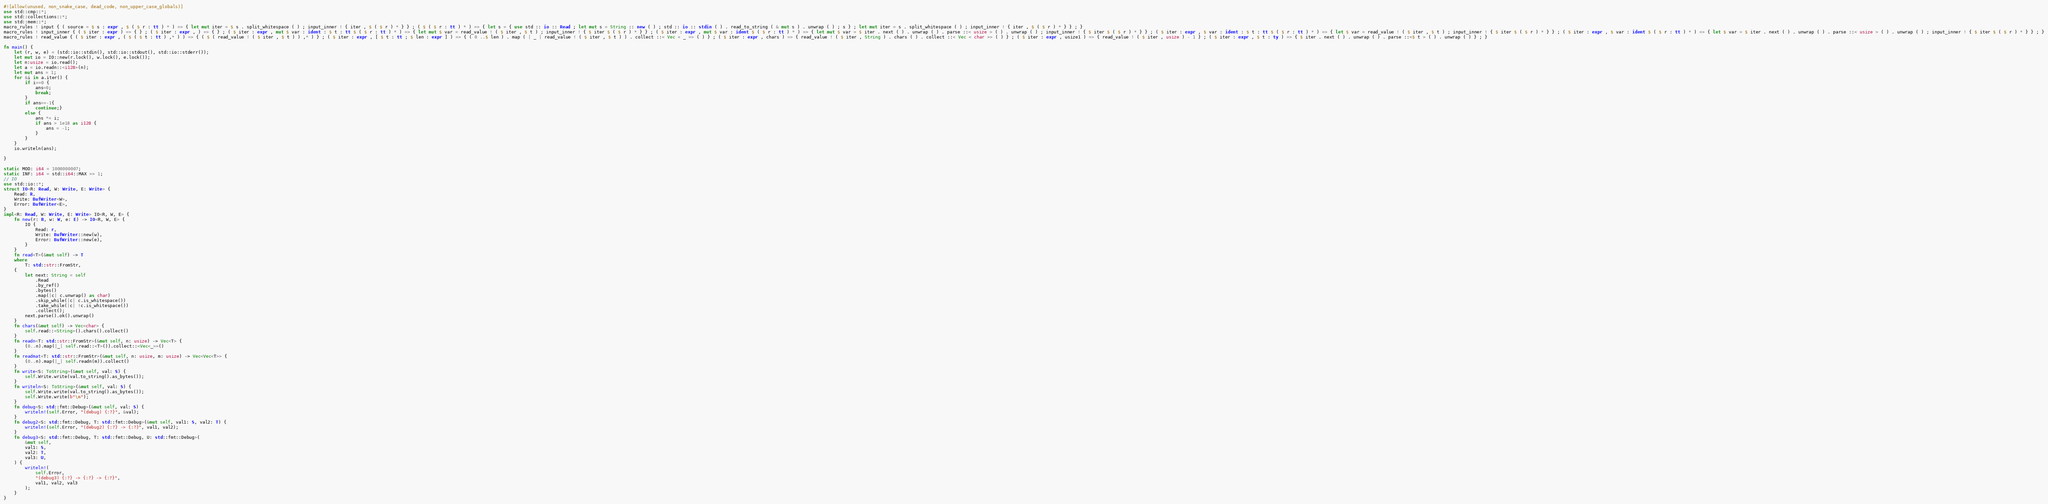<code> <loc_0><loc_0><loc_500><loc_500><_Rust_>#![allow(unused, non_snake_case, dead_code, non_upper_case_globals)]
use std::cmp::*;
use std::collections::*;
use std::mem::*;
macro_rules ! input { ( source = $ s : expr , $ ( $ r : tt ) * ) => { let mut iter = $ s . split_whitespace ( ) ; input_inner ! { iter , $ ( $ r ) * } } ; ( $ ( $ r : tt ) * ) => { let s = { use std :: io :: Read ; let mut s = String :: new ( ) ; std :: io :: stdin ( ) . read_to_string ( & mut s ) . unwrap ( ) ; s } ; let mut iter = s . split_whitespace ( ) ; input_inner ! { iter , $ ( $ r ) * } } ; }
macro_rules ! input_inner { ( $ iter : expr ) => { } ; ( $ iter : expr , ) => { } ; ( $ iter : expr , mut $ var : ident : $ t : tt $ ( $ r : tt ) * ) => { let mut $ var = read_value ! ( $ iter , $ t ) ; input_inner ! { $ iter $ ( $ r ) * } } ; ( $ iter : expr , mut $ var : ident $ ( $ r : tt ) * ) => { let mut $ var = $ iter . next ( ) . unwrap ( ) . parse ::< usize > ( ) . unwrap ( ) ; input_inner ! { $ iter $ ( $ r ) * } } ; ( $ iter : expr , $ var : ident : $ t : tt $ ( $ r : tt ) * ) => { let $ var = read_value ! ( $ iter , $ t ) ; input_inner ! { $ iter $ ( $ r ) * } } ; ( $ iter : expr , $ var : ident $ ( $ r : tt ) * ) => { let $ var = $ iter . next ( ) . unwrap ( ) . parse ::< usize > ( ) . unwrap ( ) ; input_inner ! { $ iter $ ( $ r ) * } } ; }
macro_rules ! read_value { ( $ iter : expr , ( $ ( $ t : tt ) ,* ) ) => { ( $ ( read_value ! ( $ iter , $ t ) ) ,* ) } ; ( $ iter : expr , [ $ t : tt ; $ len : expr ] ) => { ( 0 ..$ len ) . map ( | _ | read_value ! ( $ iter , $ t ) ) . collect ::< Vec < _ >> ( ) } ; ( $ iter : expr , chars ) => { read_value ! ( $ iter , String ) . chars ( ) . collect ::< Vec < char >> ( ) } ; ( $ iter : expr , usize1 ) => { read_value ! ( $ iter , usize ) - 1 } ; ( $ iter : expr , $ t : ty ) => { $ iter . next ( ) . unwrap ( ) . parse ::<$ t > ( ) . unwrap ( ) } ; }

fn main() {
    let (r, w, e) = (std::io::stdin(), std::io::stdout(), std::io::stderr());
    let mut io = IO::new(r.lock(), w.lock(), e.lock());
    let n:usize = io.read();
    let a = io.readn::<i128>(n);
    let mut ans = 1;
    for &i in a.iter() {
        if i==0 {
            ans=0;
            break;
        }
        if ans==-1{
            continue;}
        else {
            ans *= i;
            if ans > 1e18 as i128 {
                ans = -1;
            }
        }
    }
    io.writeln(ans);

}

static MOD: i64 = 1000000007;
static INF: i64 = std::i64::MAX >> 1;
// IO
use std::io::*;
struct IO<R: Read, W: Write, E: Write> {
    Read: R,
    Write: BufWriter<W>,
    Error: BufWriter<E>,
}
impl<R: Read, W: Write, E: Write> IO<R, W, E> {
    fn new(r: R, w: W, e: E) -> IO<R, W, E> {
        IO {
            Read: r,
            Write: BufWriter::new(w),
            Error: BufWriter::new(e),
        }
    }
    fn read<T>(&mut self) -> T
    where
        T: std::str::FromStr,
    {
        let next: String = self
            .Read
            .by_ref()
            .bytes()
            .map(|c| c.unwrap() as char)
            .skip_while(|c| c.is_whitespace())
            .take_while(|c| !c.is_whitespace())
            .collect();
        next.parse().ok().unwrap()
    }
    fn chars(&mut self) -> Vec<char> {
        self.read::<String>().chars().collect()
    }
    fn readn<T: std::str::FromStr>(&mut self, n: usize) -> Vec<T> {
        (0..n).map(|_| self.read::<T>()).collect::<Vec<_>>()
    }
    fn readmat<T: std::str::FromStr>(&mut self, n: usize, m: usize) -> Vec<Vec<T>> {
        (0..n).map(|_| self.readn(m)).collect()
    }
    fn write<S: ToString>(&mut self, val: S) {
        self.Write.write(val.to_string().as_bytes());
    }
    fn writeln<S: ToString>(&mut self, val: S) {
        self.Write.write(val.to_string().as_bytes());
        self.Write.write(b"\n");
    }
    fn debug<S: std::fmt::Debug>(&mut self, val: S) {
        writeln!(self.Error, "(debug) {:?}", &val);
    }
    fn debug2<S: std::fmt::Debug, T: std::fmt::Debug>(&mut self, val1: S, val2: T) {
        writeln!(self.Error, "(debug2) {:?} -> {:?}", val1, val2);
    }
    fn debug3<S: std::fmt::Debug, T: std::fmt::Debug, U: std::fmt::Debug>(
        &mut self,
        val1: S,
        val2: T,
        val3: U,
    ) {
        writeln!(
            self.Error,
            "(debug3) {:?} -> {:?} -> {:?}",
            val1, val2, val3
        );
    }
}
</code> 